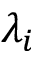<formula> <loc_0><loc_0><loc_500><loc_500>\lambda _ { i }</formula> 